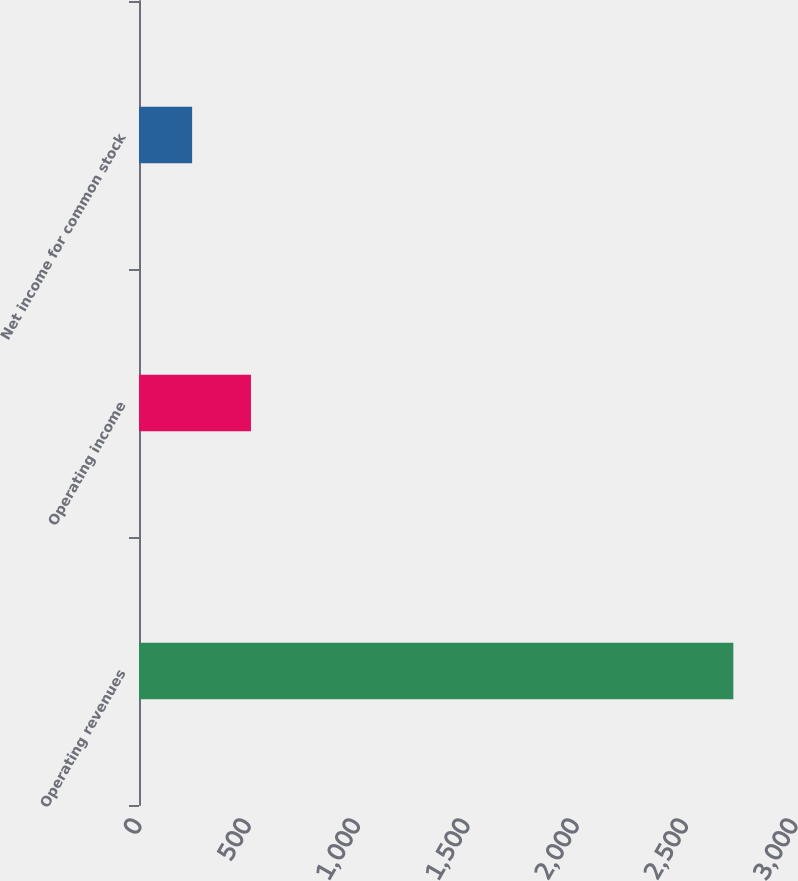<chart> <loc_0><loc_0><loc_500><loc_500><bar_chart><fcel>Operating revenues<fcel>Operating income<fcel>Net income for common stock<nl><fcel>2718<fcel>512<fcel>243<nl></chart> 